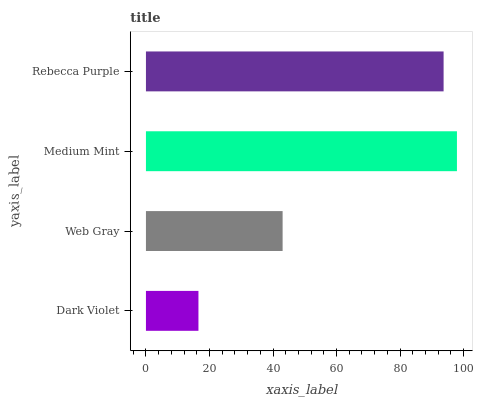Is Dark Violet the minimum?
Answer yes or no. Yes. Is Medium Mint the maximum?
Answer yes or no. Yes. Is Web Gray the minimum?
Answer yes or no. No. Is Web Gray the maximum?
Answer yes or no. No. Is Web Gray greater than Dark Violet?
Answer yes or no. Yes. Is Dark Violet less than Web Gray?
Answer yes or no. Yes. Is Dark Violet greater than Web Gray?
Answer yes or no. No. Is Web Gray less than Dark Violet?
Answer yes or no. No. Is Rebecca Purple the high median?
Answer yes or no. Yes. Is Web Gray the low median?
Answer yes or no. Yes. Is Medium Mint the high median?
Answer yes or no. No. Is Dark Violet the low median?
Answer yes or no. No. 